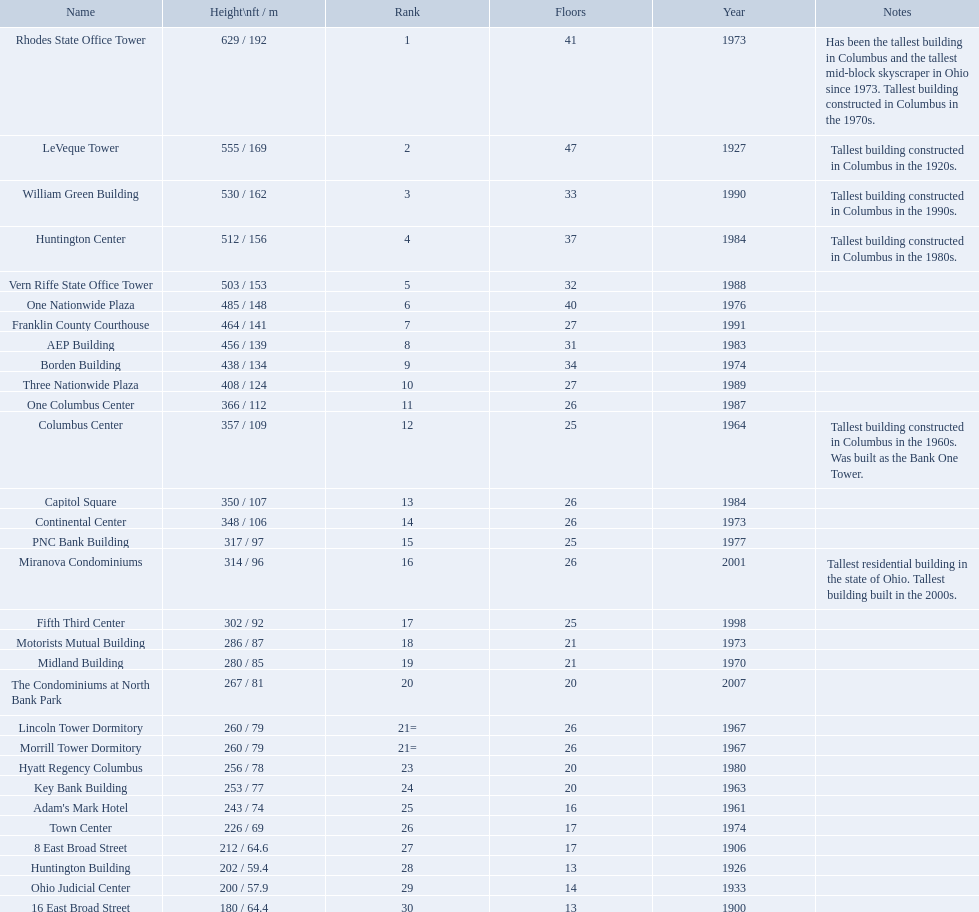Which of the tallest buildings in columbus, ohio were built in the 1980s? Huntington Center, Vern Riffe State Office Tower, AEP Building, Three Nationwide Plaza, One Columbus Center, Capitol Square, Hyatt Regency Columbus. Of these buildings, which have between 26 and 31 floors? AEP Building, Three Nationwide Plaza, One Columbus Center, Capitol Square. Of these buildings, which is the tallest? AEP Building. 